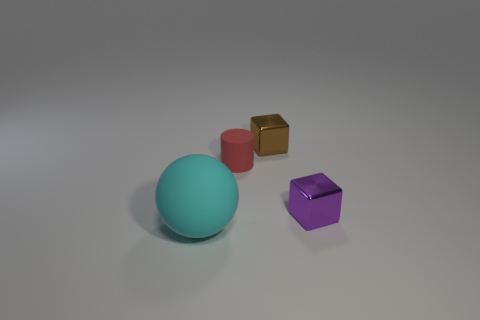Add 1 shiny blocks. How many objects exist? 5 Subtract all cylinders. How many objects are left? 3 Add 4 brown blocks. How many brown blocks exist? 5 Subtract 0 purple cylinders. How many objects are left? 4 Subtract all shiny cylinders. Subtract all small cylinders. How many objects are left? 3 Add 1 metallic objects. How many metallic objects are left? 3 